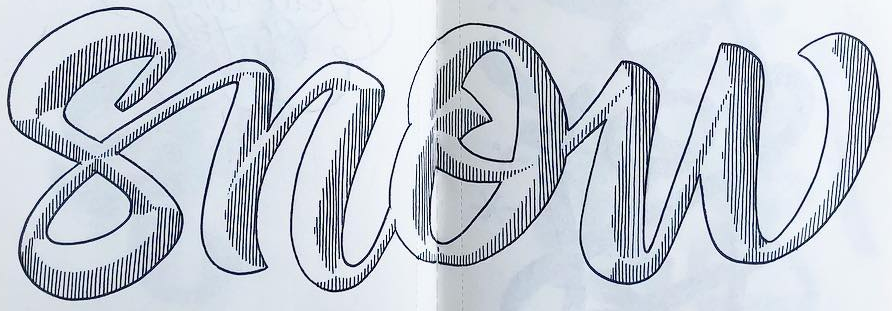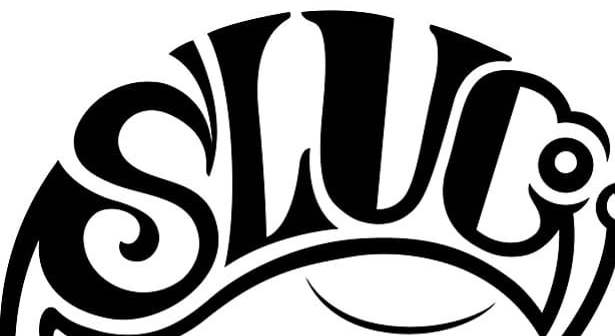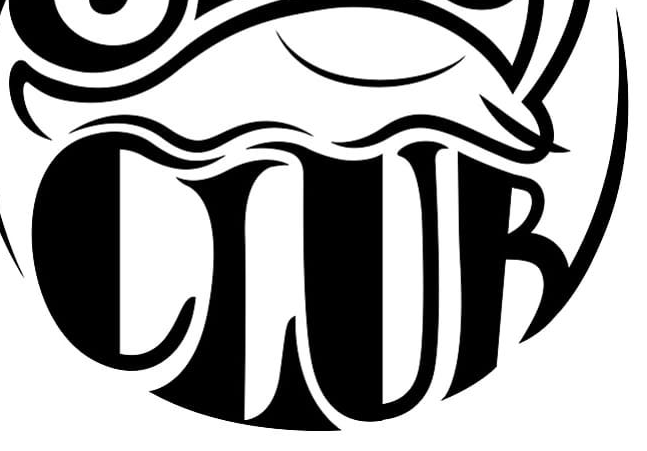What words are shown in these images in order, separated by a semicolon? snow; SLUC; CLUB 